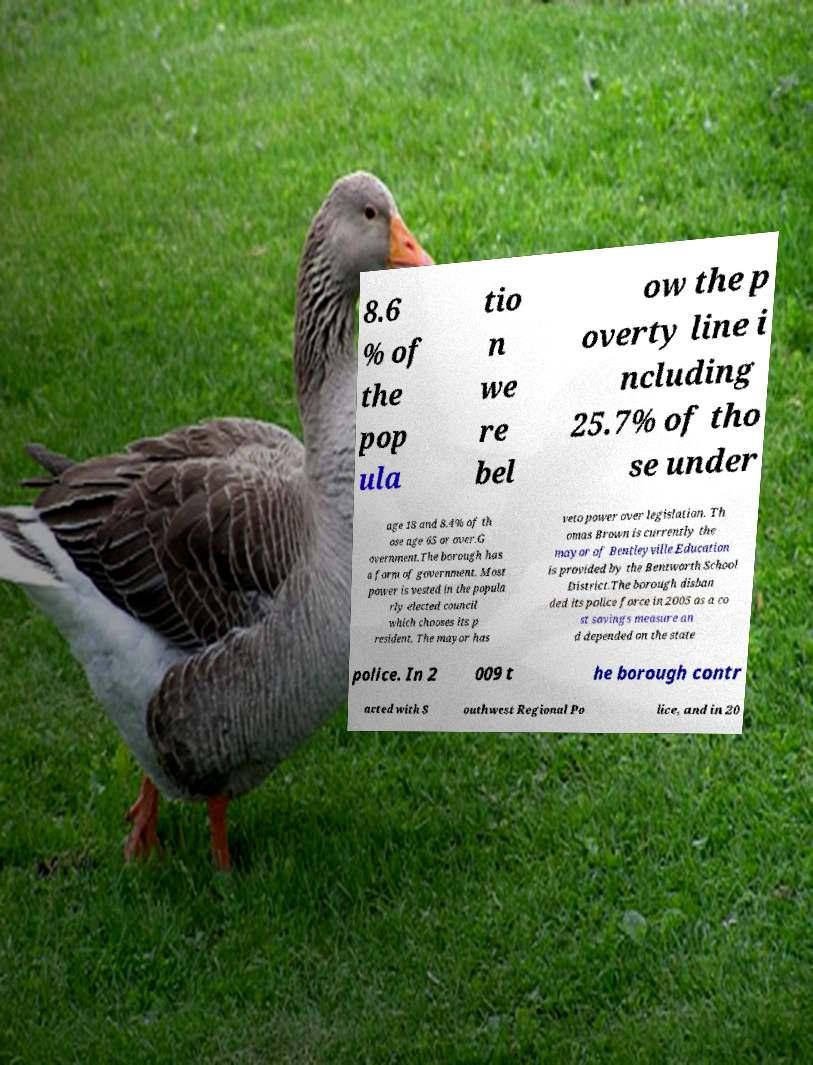Could you assist in decoding the text presented in this image and type it out clearly? 8.6 % of the pop ula tio n we re bel ow the p overty line i ncluding 25.7% of tho se under age 18 and 8.4% of th ose age 65 or over.G overnment.The borough has a form of government. Most power is vested in the popula rly elected council which chooses its p resident. The mayor has veto power over legislation. Th omas Brown is currently the mayor of Bentleyville.Education is provided by the Bentworth School District.The borough disban ded its police force in 2005 as a co st savings measure an d depended on the state police. In 2 009 t he borough contr acted with S outhwest Regional Po lice, and in 20 